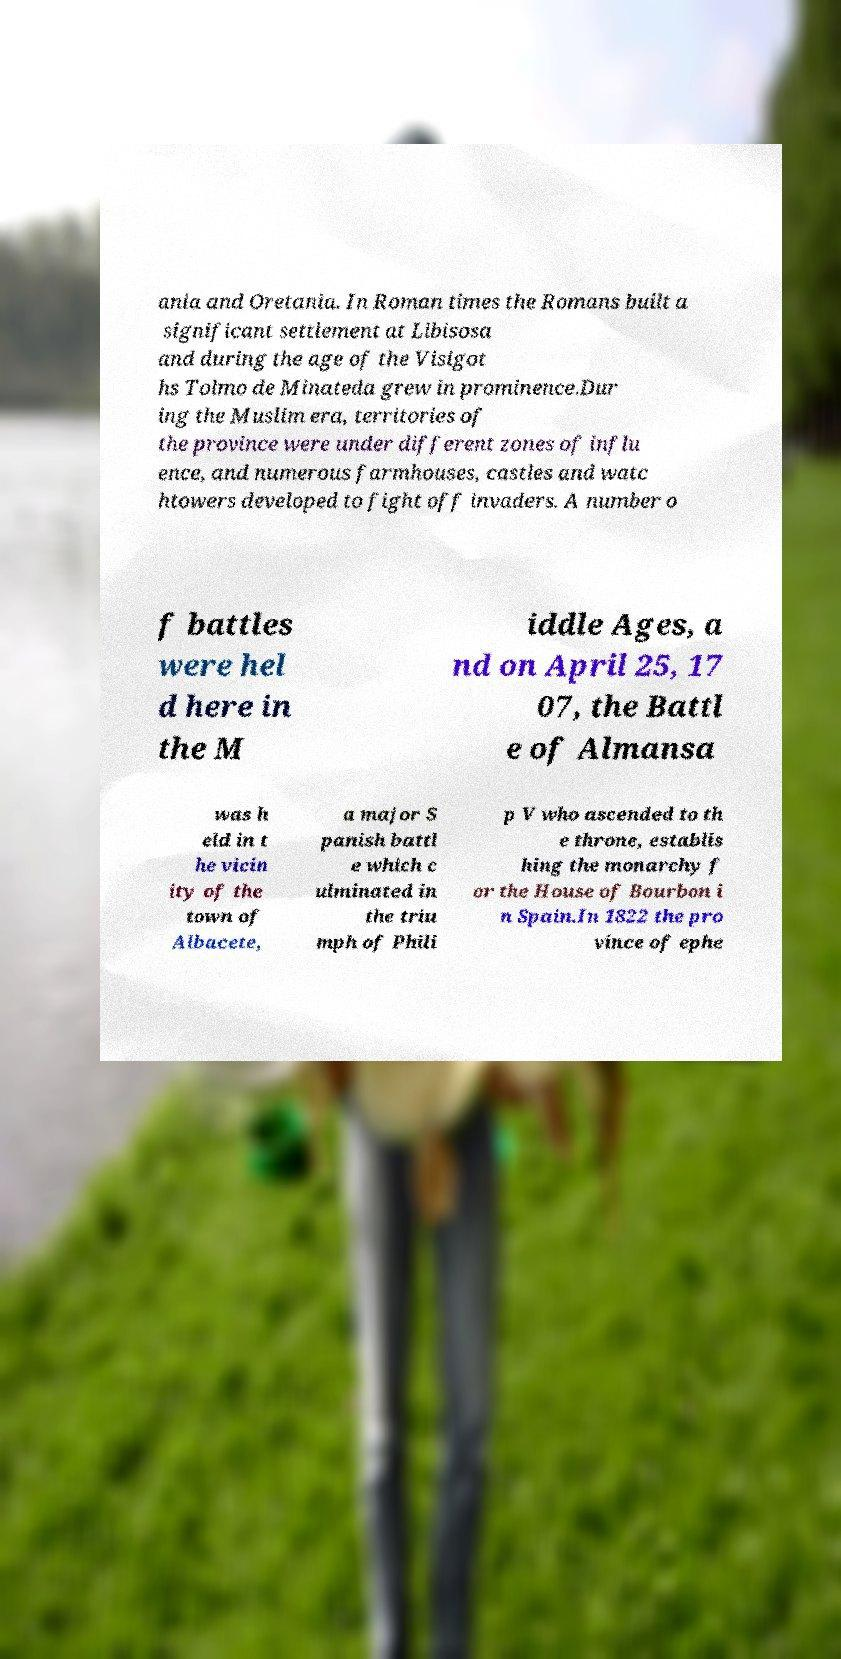Please read and relay the text visible in this image. What does it say? ania and Oretania. In Roman times the Romans built a significant settlement at Libisosa and during the age of the Visigot hs Tolmo de Minateda grew in prominence.Dur ing the Muslim era, territories of the province were under different zones of influ ence, and numerous farmhouses, castles and watc htowers developed to fight off invaders. A number o f battles were hel d here in the M iddle Ages, a nd on April 25, 17 07, the Battl e of Almansa was h eld in t he vicin ity of the town of Albacete, a major S panish battl e which c ulminated in the triu mph of Phili p V who ascended to th e throne, establis hing the monarchy f or the House of Bourbon i n Spain.In 1822 the pro vince of ephe 